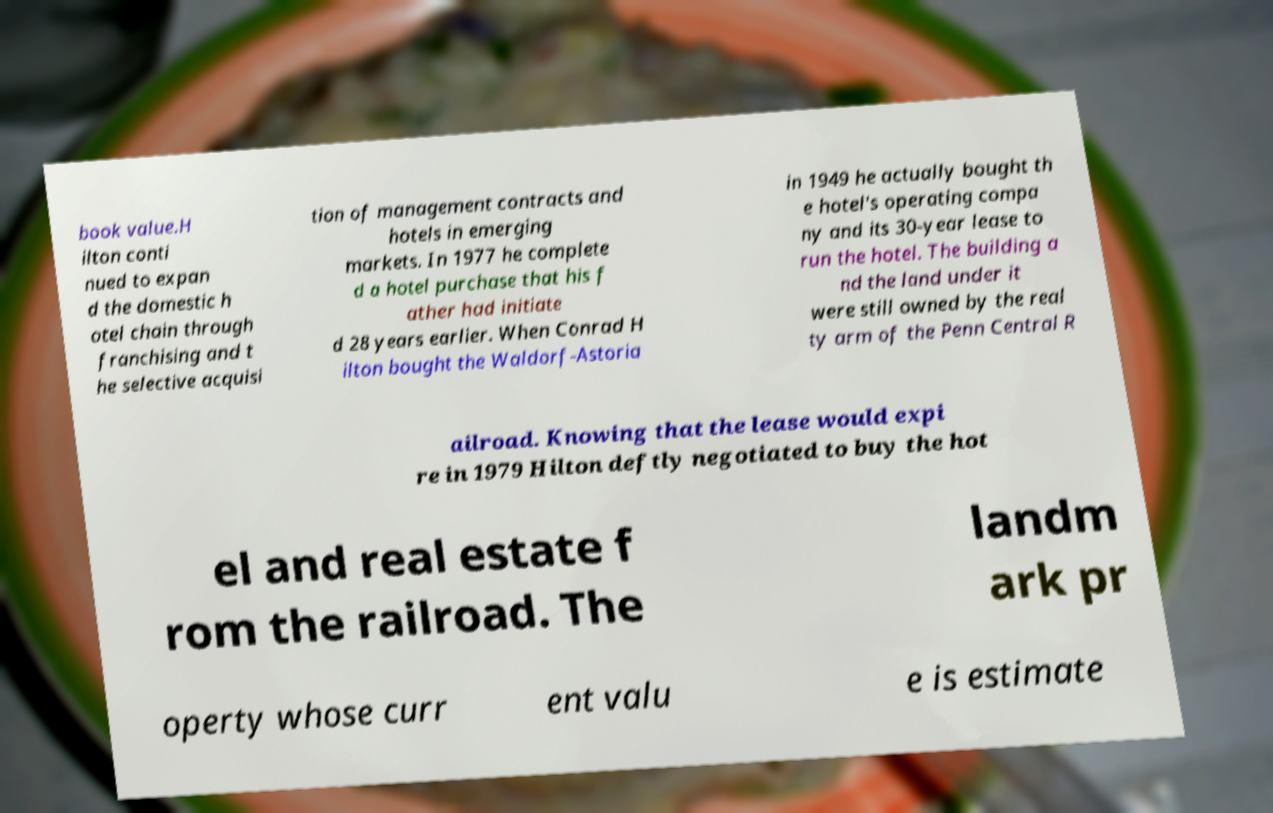Can you read and provide the text displayed in the image?This photo seems to have some interesting text. Can you extract and type it out for me? book value.H ilton conti nued to expan d the domestic h otel chain through franchising and t he selective acquisi tion of management contracts and hotels in emerging markets. In 1977 he complete d a hotel purchase that his f ather had initiate d 28 years earlier. When Conrad H ilton bought the Waldorf-Astoria in 1949 he actually bought th e hotel's operating compa ny and its 30-year lease to run the hotel. The building a nd the land under it were still owned by the real ty arm of the Penn Central R ailroad. Knowing that the lease would expi re in 1979 Hilton deftly negotiated to buy the hot el and real estate f rom the railroad. The landm ark pr operty whose curr ent valu e is estimate 